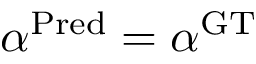Convert formula to latex. <formula><loc_0><loc_0><loc_500><loc_500>\alpha ^ { P r e d } = \alpha ^ { G T }</formula> 